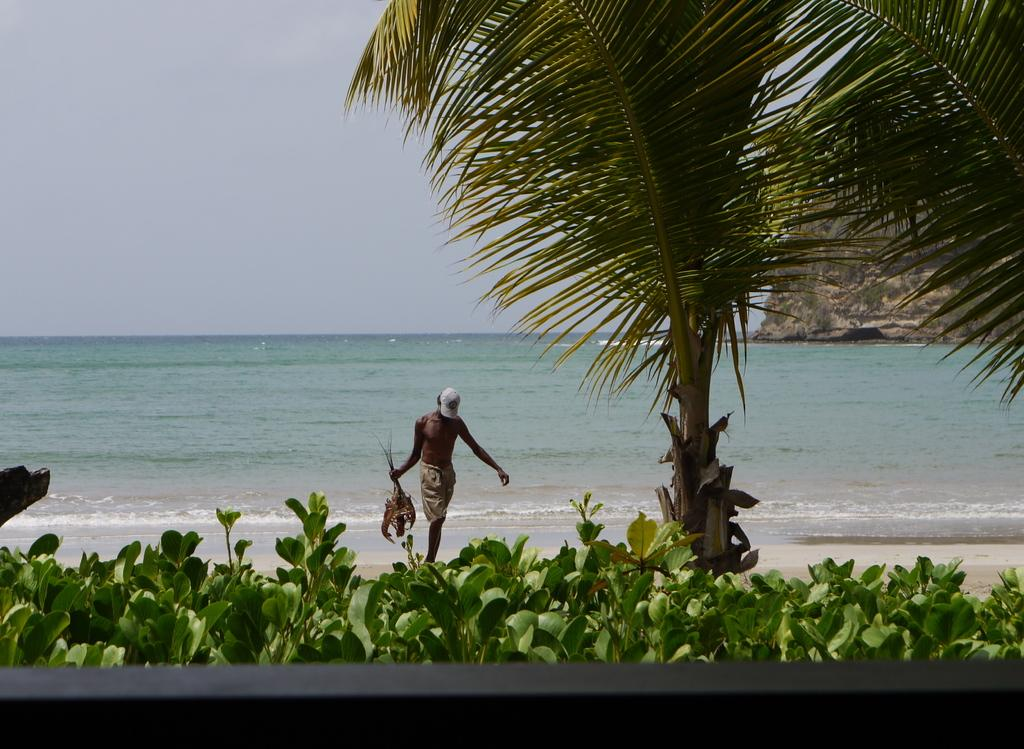What is the person in the image holding? The person is holding a fish. Where is the person located in the image? The person is standing on the seashore. What can be seen in the background of the image? There is sky, trees, plants, and a tree visible in the background of the image. Can you describe the landscape in the background of the image? There is a hill in the background of the image. What type of appliance is the person using to catch the fish in the image? There is no appliance visible in the image; the person is holding a fish they likely caught using a fishing rod or net. How many pets are visible in the image? There are no pets present in the image. 